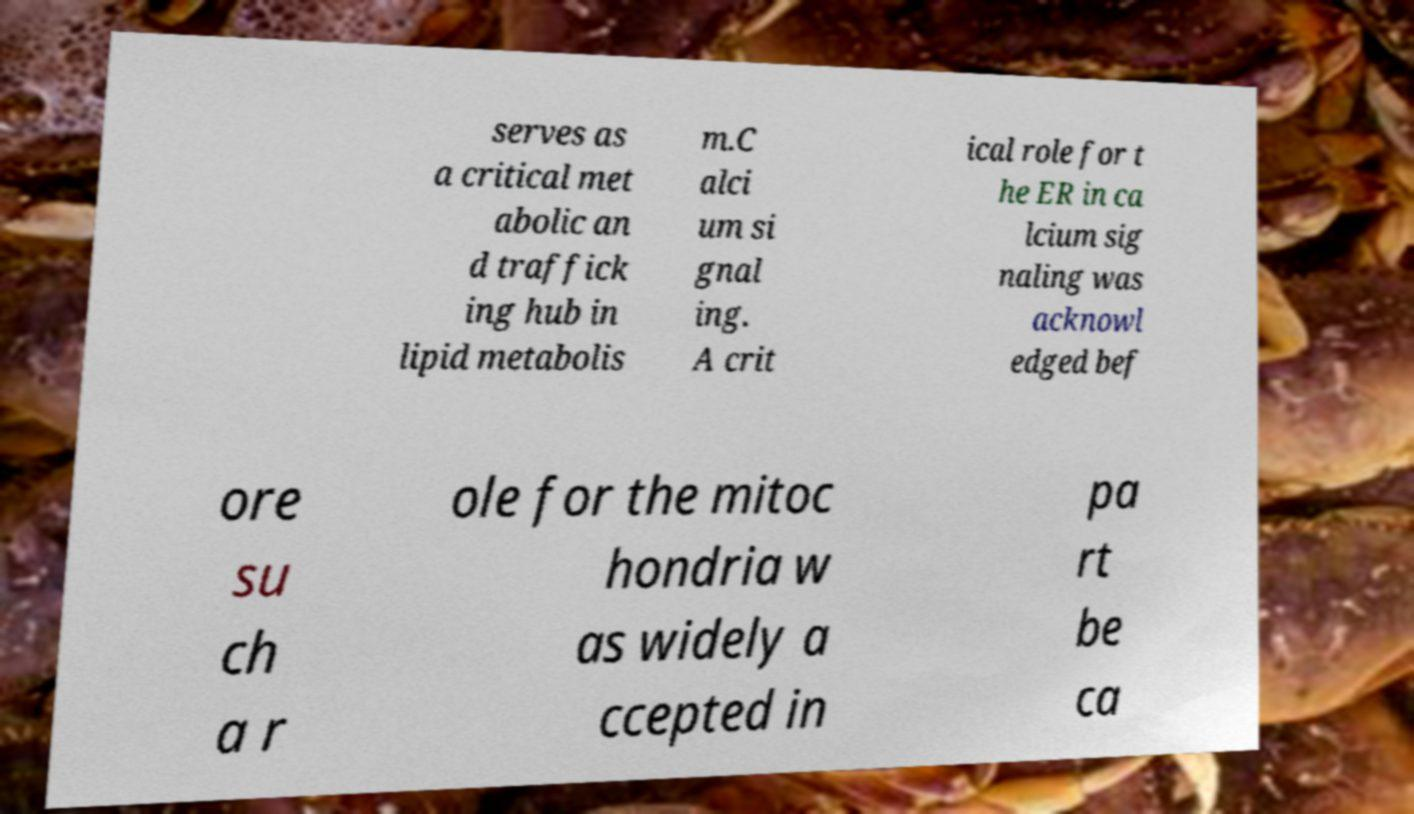There's text embedded in this image that I need extracted. Can you transcribe it verbatim? serves as a critical met abolic an d traffick ing hub in lipid metabolis m.C alci um si gnal ing. A crit ical role for t he ER in ca lcium sig naling was acknowl edged bef ore su ch a r ole for the mitoc hondria w as widely a ccepted in pa rt be ca 